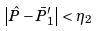<formula> <loc_0><loc_0><loc_500><loc_500>\left | \hat { P } - \bar { P } _ { 1 } ^ { \prime } \right | < \eta _ { 2 }</formula> 